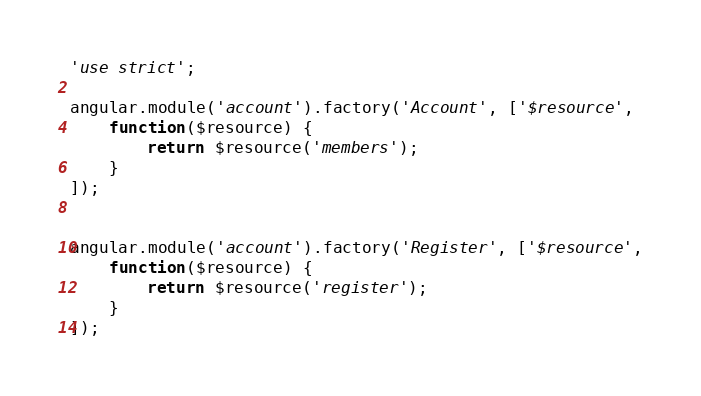Convert code to text. <code><loc_0><loc_0><loc_500><loc_500><_JavaScript_>'use strict';

angular.module('account').factory('Account', ['$resource',
	function($resource) {
		return $resource('members');
	}
]);


angular.module('account').factory('Register', ['$resource',
	function($resource) {
		return $resource('register');
	}
]);</code> 